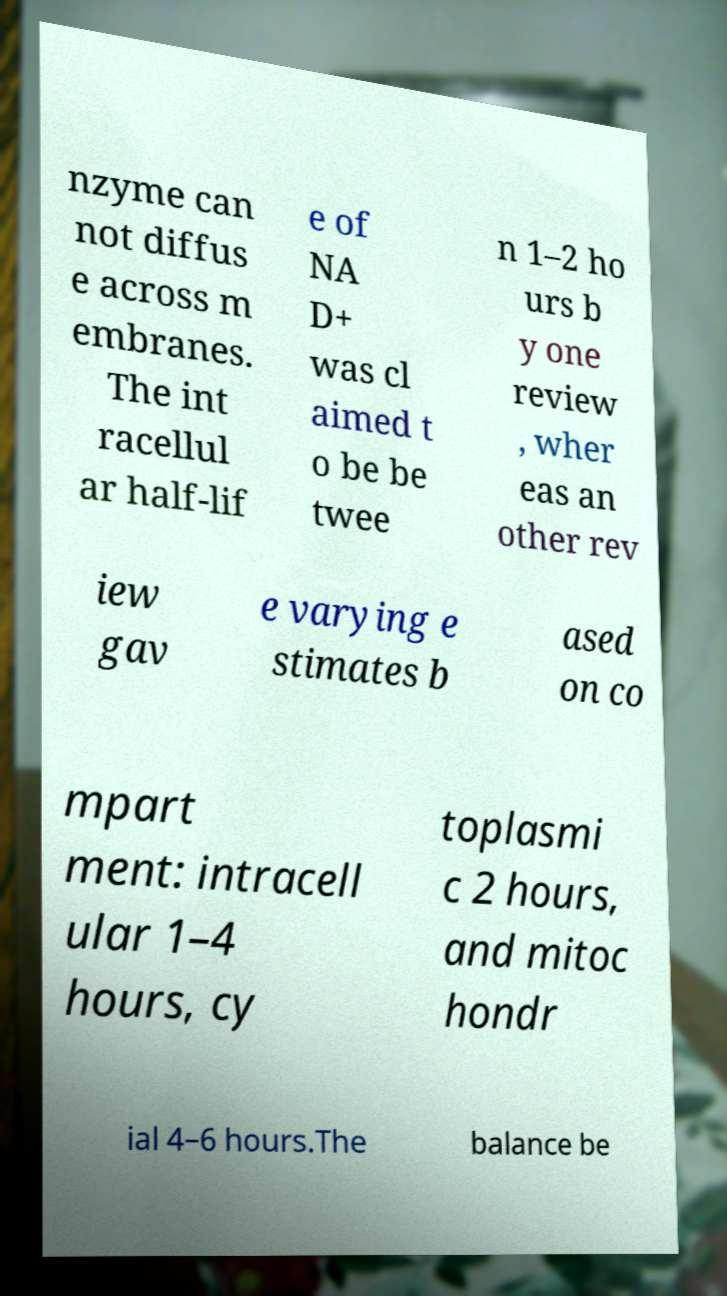Can you read and provide the text displayed in the image?This photo seems to have some interesting text. Can you extract and type it out for me? nzyme can not diffus e across m embranes. The int racellul ar half-lif e of NA D+ was cl aimed t o be be twee n 1–2 ho urs b y one review , wher eas an other rev iew gav e varying e stimates b ased on co mpart ment: intracell ular 1–4 hours, cy toplasmi c 2 hours, and mitoc hondr ial 4–6 hours.The balance be 